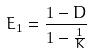Convert formula to latex. <formula><loc_0><loc_0><loc_500><loc_500>E _ { 1 } = \frac { 1 - D } { 1 - \frac { 1 } { K } }</formula> 